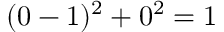Convert formula to latex. <formula><loc_0><loc_0><loc_500><loc_500>( 0 - 1 ) ^ { 2 } + 0 ^ { 2 } = 1</formula> 